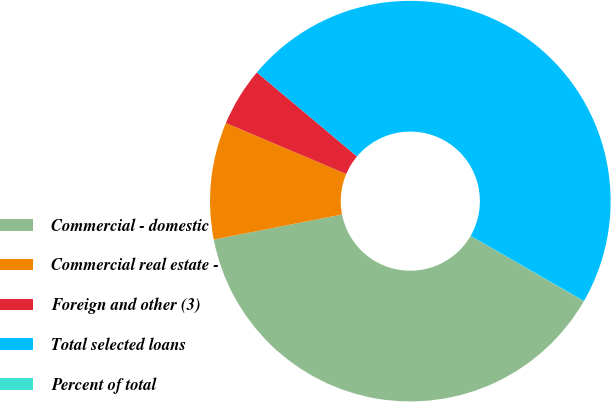Convert chart. <chart><loc_0><loc_0><loc_500><loc_500><pie_chart><fcel>Commercial - domestic<fcel>Commercial real estate -<fcel>Foreign and other (3)<fcel>Total selected loans<fcel>Percent of total<nl><fcel>38.6%<fcel>9.45%<fcel>4.73%<fcel>47.2%<fcel>0.02%<nl></chart> 